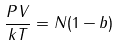Convert formula to latex. <formula><loc_0><loc_0><loc_500><loc_500>\frac { P V } { k T } = N ( 1 - b )</formula> 